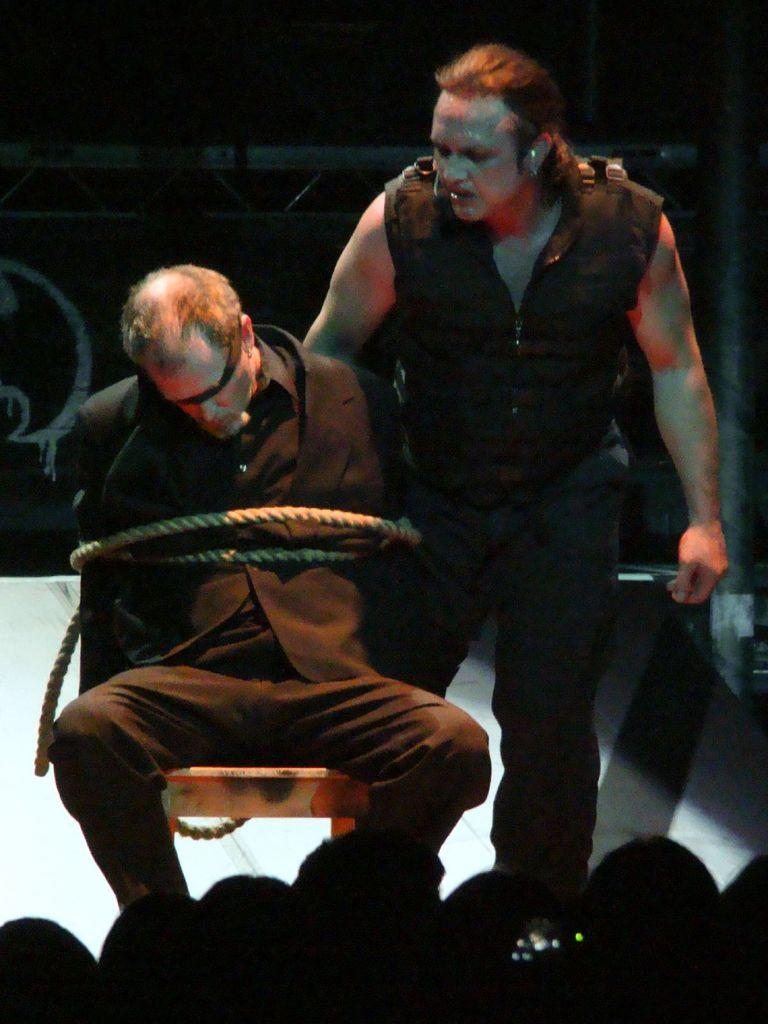What is happening to the person in the image? There is a person tied to a chair in the image. Who else is present in the image? There is another person standing behind the tied person, and there are a few people in front of the standing person. What objects can be seen in the image? There are metal rods visible in the image. What type of calendar is hanging on the wall in the image? There is no calendar present in the image. 